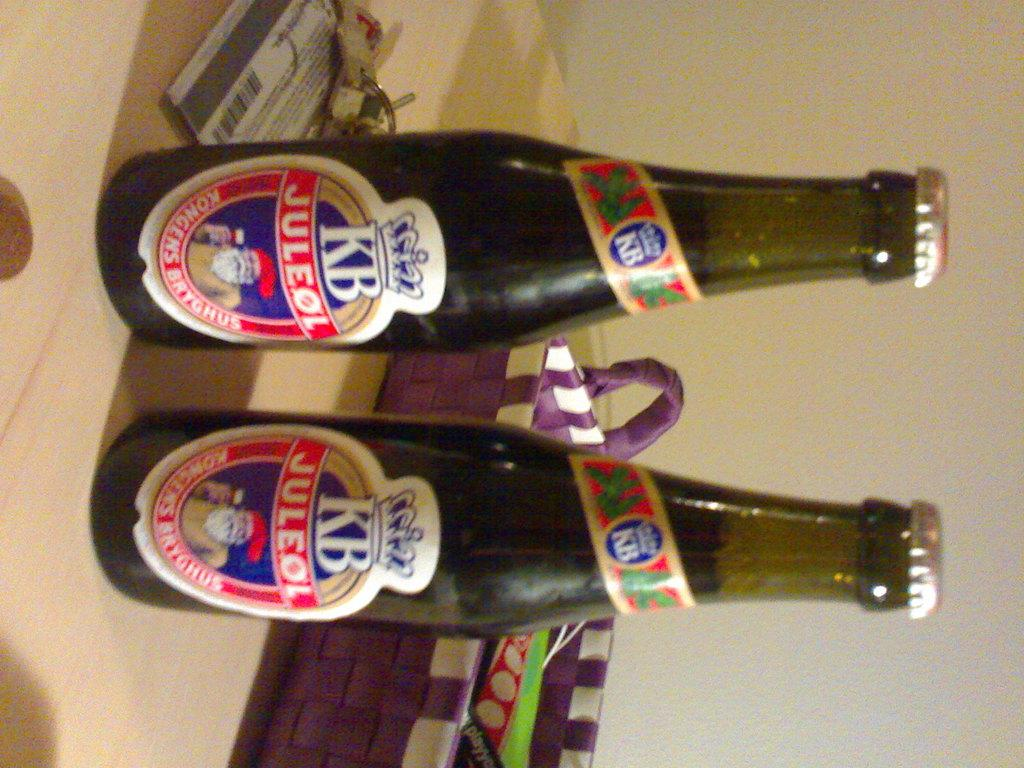Provide a one-sentence caption for the provided image. Two beer bottles of KB Juleol sitting on a table by some keys. 